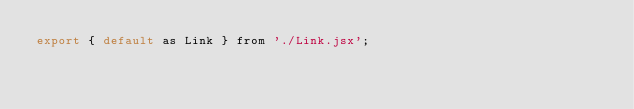Convert code to text. <code><loc_0><loc_0><loc_500><loc_500><_JavaScript_>export { default as Link } from './Link.jsx';
</code> 